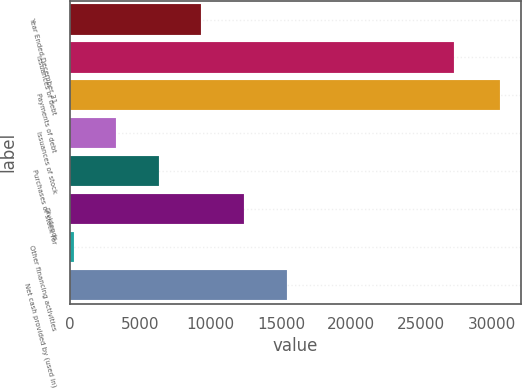Convert chart to OTSL. <chart><loc_0><loc_0><loc_500><loc_500><bar_chart><fcel>Year Ended December 31<fcel>Issuances of debt<fcel>Payments of debt<fcel>Issuances of stock<fcel>Purchases of stock for<fcel>Dividends<fcel>Other financing activities<fcel>Net cash provided by (used in)<nl><fcel>9340.5<fcel>27339<fcel>30568<fcel>3275.5<fcel>6308<fcel>12373<fcel>243<fcel>15405.5<nl></chart> 